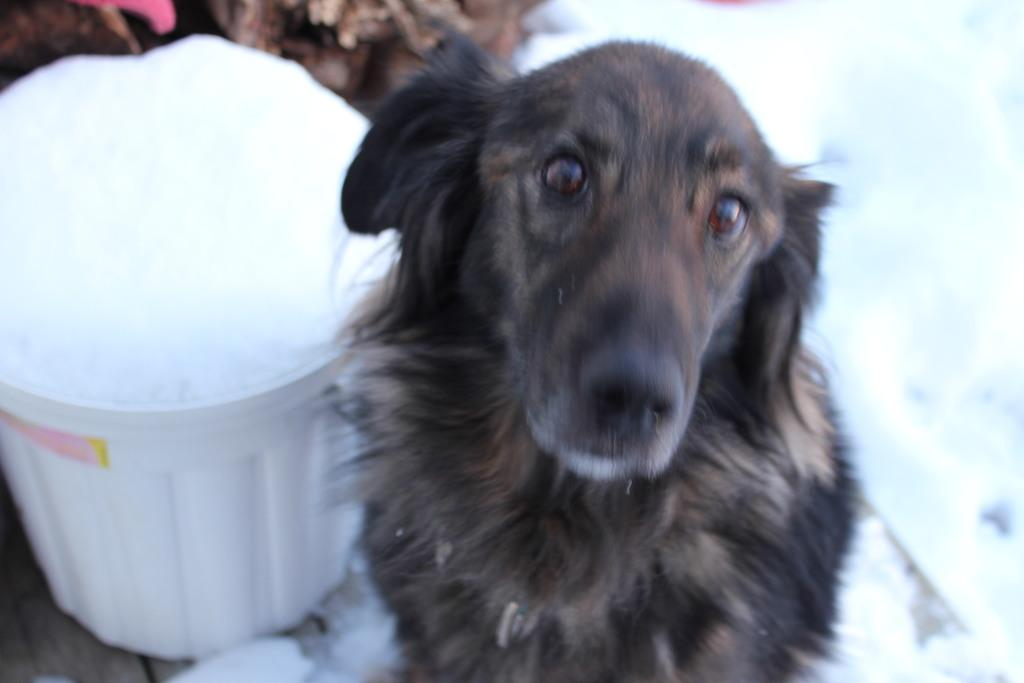What type of animal is present in the image? There is a black color dog in the image. What else can be seen in the image besides the dog? There is a container in the image. What type of yak is visible in the image? There is no yak present in the image; it features a black color dog and a container. 